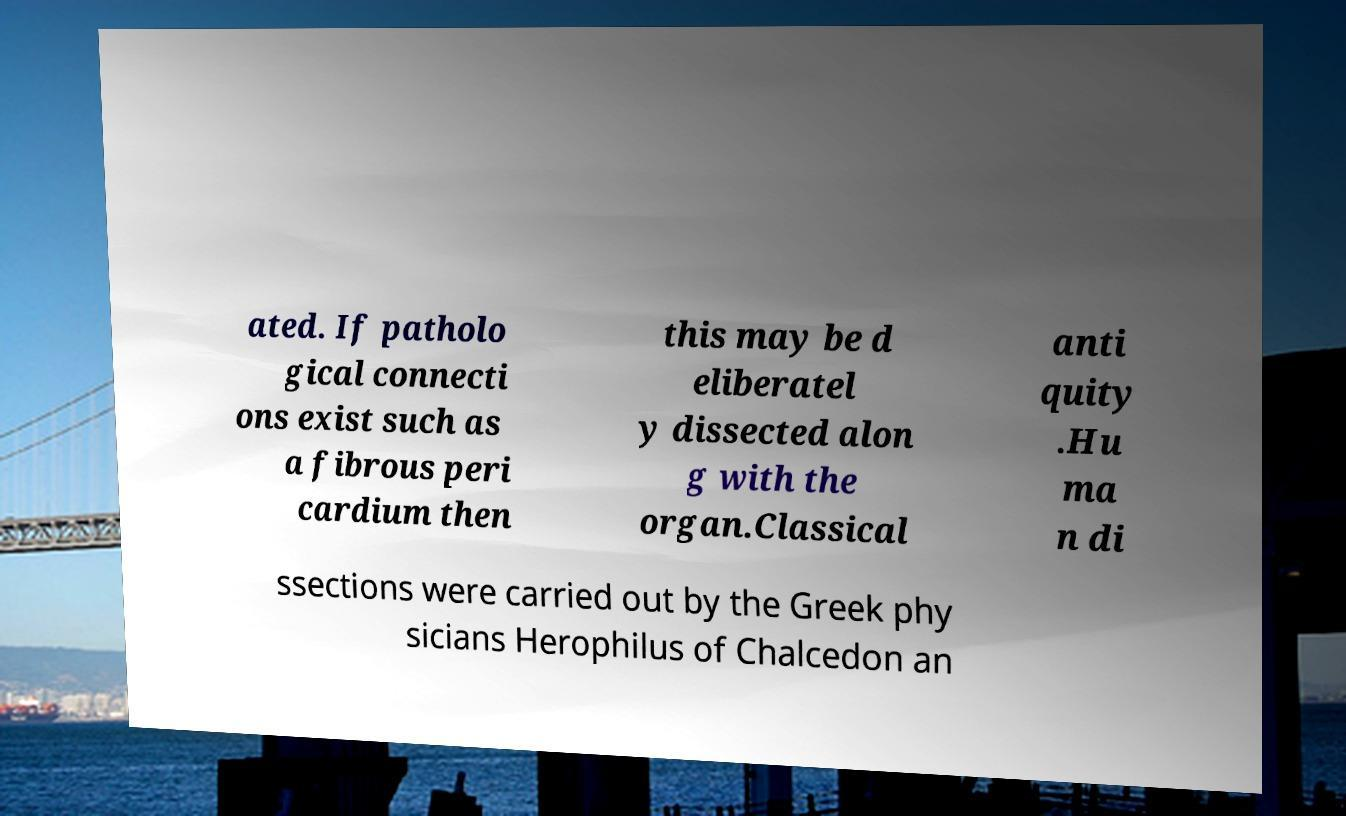There's text embedded in this image that I need extracted. Can you transcribe it verbatim? ated. If patholo gical connecti ons exist such as a fibrous peri cardium then this may be d eliberatel y dissected alon g with the organ.Classical anti quity .Hu ma n di ssections were carried out by the Greek phy sicians Herophilus of Chalcedon an 